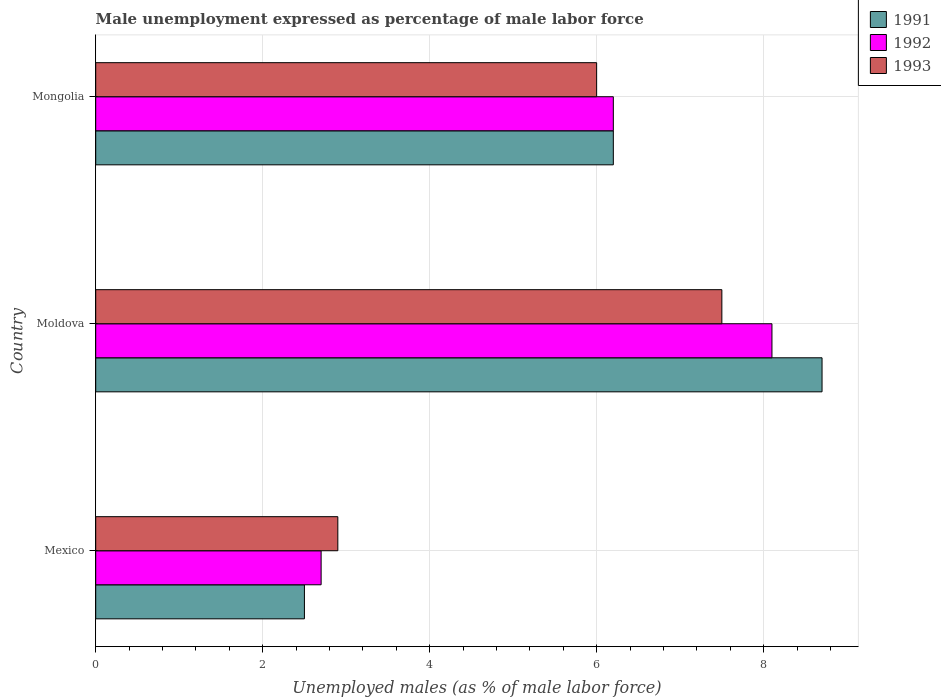How many different coloured bars are there?
Your answer should be very brief. 3. How many groups of bars are there?
Ensure brevity in your answer.  3. Are the number of bars on each tick of the Y-axis equal?
Keep it short and to the point. Yes. How many bars are there on the 3rd tick from the top?
Your answer should be compact. 3. How many bars are there on the 1st tick from the bottom?
Your response must be concise. 3. What is the label of the 3rd group of bars from the top?
Provide a succinct answer. Mexico. In how many cases, is the number of bars for a given country not equal to the number of legend labels?
Provide a succinct answer. 0. What is the unemployment in males in in 1993 in Mongolia?
Your answer should be compact. 6. Across all countries, what is the maximum unemployment in males in in 1991?
Offer a terse response. 8.7. Across all countries, what is the minimum unemployment in males in in 1992?
Give a very brief answer. 2.7. In which country was the unemployment in males in in 1991 maximum?
Provide a short and direct response. Moldova. What is the total unemployment in males in in 1991 in the graph?
Make the answer very short. 17.4. What is the difference between the unemployment in males in in 1991 in Mexico and that in Mongolia?
Provide a short and direct response. -3.7. What is the difference between the unemployment in males in in 1992 in Moldova and the unemployment in males in in 1993 in Mexico?
Provide a short and direct response. 5.2. What is the average unemployment in males in in 1993 per country?
Your answer should be compact. 5.47. What is the difference between the unemployment in males in in 1992 and unemployment in males in in 1991 in Moldova?
Make the answer very short. -0.6. What is the ratio of the unemployment in males in in 1992 in Mexico to that in Mongolia?
Your answer should be very brief. 0.44. What is the difference between the highest and the second highest unemployment in males in in 1993?
Keep it short and to the point. 1.5. What is the difference between the highest and the lowest unemployment in males in in 1991?
Provide a succinct answer. 6.2. In how many countries, is the unemployment in males in in 1992 greater than the average unemployment in males in in 1992 taken over all countries?
Your answer should be compact. 2. Is the sum of the unemployment in males in in 1993 in Mexico and Mongolia greater than the maximum unemployment in males in in 1991 across all countries?
Provide a succinct answer. Yes. What does the 3rd bar from the top in Moldova represents?
Offer a terse response. 1991. What does the 1st bar from the bottom in Mexico represents?
Offer a very short reply. 1991. Are all the bars in the graph horizontal?
Your answer should be compact. Yes. How many countries are there in the graph?
Your answer should be very brief. 3. Are the values on the major ticks of X-axis written in scientific E-notation?
Your answer should be compact. No. Where does the legend appear in the graph?
Keep it short and to the point. Top right. How are the legend labels stacked?
Your answer should be compact. Vertical. What is the title of the graph?
Ensure brevity in your answer.  Male unemployment expressed as percentage of male labor force. What is the label or title of the X-axis?
Your answer should be very brief. Unemployed males (as % of male labor force). What is the Unemployed males (as % of male labor force) of 1992 in Mexico?
Offer a terse response. 2.7. What is the Unemployed males (as % of male labor force) of 1993 in Mexico?
Provide a succinct answer. 2.9. What is the Unemployed males (as % of male labor force) of 1991 in Moldova?
Your answer should be compact. 8.7. What is the Unemployed males (as % of male labor force) of 1992 in Moldova?
Your response must be concise. 8.1. What is the Unemployed males (as % of male labor force) of 1993 in Moldova?
Your answer should be compact. 7.5. What is the Unemployed males (as % of male labor force) in 1991 in Mongolia?
Your answer should be very brief. 6.2. What is the Unemployed males (as % of male labor force) in 1992 in Mongolia?
Your answer should be very brief. 6.2. What is the Unemployed males (as % of male labor force) in 1993 in Mongolia?
Provide a short and direct response. 6. Across all countries, what is the maximum Unemployed males (as % of male labor force) of 1991?
Your response must be concise. 8.7. Across all countries, what is the maximum Unemployed males (as % of male labor force) in 1992?
Provide a short and direct response. 8.1. Across all countries, what is the maximum Unemployed males (as % of male labor force) of 1993?
Provide a short and direct response. 7.5. Across all countries, what is the minimum Unemployed males (as % of male labor force) of 1991?
Ensure brevity in your answer.  2.5. Across all countries, what is the minimum Unemployed males (as % of male labor force) in 1992?
Keep it short and to the point. 2.7. Across all countries, what is the minimum Unemployed males (as % of male labor force) in 1993?
Make the answer very short. 2.9. What is the total Unemployed males (as % of male labor force) of 1991 in the graph?
Ensure brevity in your answer.  17.4. What is the difference between the Unemployed males (as % of male labor force) of 1991 in Mexico and that in Moldova?
Provide a succinct answer. -6.2. What is the difference between the Unemployed males (as % of male labor force) in 1992 in Mexico and that in Moldova?
Ensure brevity in your answer.  -5.4. What is the difference between the Unemployed males (as % of male labor force) of 1993 in Mexico and that in Moldova?
Provide a succinct answer. -4.6. What is the difference between the Unemployed males (as % of male labor force) in 1991 in Mexico and that in Mongolia?
Offer a terse response. -3.7. What is the difference between the Unemployed males (as % of male labor force) of 1992 in Mexico and that in Mongolia?
Your answer should be very brief. -3.5. What is the difference between the Unemployed males (as % of male labor force) in 1992 in Moldova and that in Mongolia?
Make the answer very short. 1.9. What is the difference between the Unemployed males (as % of male labor force) of 1993 in Moldova and that in Mongolia?
Keep it short and to the point. 1.5. What is the difference between the Unemployed males (as % of male labor force) in 1991 in Mexico and the Unemployed males (as % of male labor force) in 1992 in Moldova?
Your answer should be compact. -5.6. What is the difference between the Unemployed males (as % of male labor force) of 1991 in Mexico and the Unemployed males (as % of male labor force) of 1993 in Moldova?
Make the answer very short. -5. What is the difference between the Unemployed males (as % of male labor force) in 1992 in Mexico and the Unemployed males (as % of male labor force) in 1993 in Moldova?
Offer a terse response. -4.8. What is the difference between the Unemployed males (as % of male labor force) in 1992 in Mexico and the Unemployed males (as % of male labor force) in 1993 in Mongolia?
Keep it short and to the point. -3.3. What is the difference between the Unemployed males (as % of male labor force) in 1991 in Moldova and the Unemployed males (as % of male labor force) in 1992 in Mongolia?
Offer a very short reply. 2.5. What is the difference between the Unemployed males (as % of male labor force) of 1991 in Moldova and the Unemployed males (as % of male labor force) of 1993 in Mongolia?
Offer a very short reply. 2.7. What is the average Unemployed males (as % of male labor force) in 1992 per country?
Offer a very short reply. 5.67. What is the average Unemployed males (as % of male labor force) of 1993 per country?
Offer a terse response. 5.47. What is the difference between the Unemployed males (as % of male labor force) of 1992 and Unemployed males (as % of male labor force) of 1993 in Mexico?
Provide a short and direct response. -0.2. What is the difference between the Unemployed males (as % of male labor force) in 1991 and Unemployed males (as % of male labor force) in 1993 in Moldova?
Offer a terse response. 1.2. What is the difference between the Unemployed males (as % of male labor force) in 1992 and Unemployed males (as % of male labor force) in 1993 in Moldova?
Your answer should be very brief. 0.6. What is the ratio of the Unemployed males (as % of male labor force) of 1991 in Mexico to that in Moldova?
Provide a short and direct response. 0.29. What is the ratio of the Unemployed males (as % of male labor force) in 1992 in Mexico to that in Moldova?
Provide a short and direct response. 0.33. What is the ratio of the Unemployed males (as % of male labor force) in 1993 in Mexico to that in Moldova?
Your answer should be compact. 0.39. What is the ratio of the Unemployed males (as % of male labor force) of 1991 in Mexico to that in Mongolia?
Make the answer very short. 0.4. What is the ratio of the Unemployed males (as % of male labor force) in 1992 in Mexico to that in Mongolia?
Your answer should be compact. 0.44. What is the ratio of the Unemployed males (as % of male labor force) in 1993 in Mexico to that in Mongolia?
Make the answer very short. 0.48. What is the ratio of the Unemployed males (as % of male labor force) of 1991 in Moldova to that in Mongolia?
Your answer should be compact. 1.4. What is the ratio of the Unemployed males (as % of male labor force) of 1992 in Moldova to that in Mongolia?
Your answer should be very brief. 1.31. What is the ratio of the Unemployed males (as % of male labor force) in 1993 in Moldova to that in Mongolia?
Your answer should be compact. 1.25. What is the difference between the highest and the second highest Unemployed males (as % of male labor force) in 1991?
Offer a very short reply. 2.5. What is the difference between the highest and the second highest Unemployed males (as % of male labor force) of 1992?
Your answer should be very brief. 1.9. What is the difference between the highest and the second highest Unemployed males (as % of male labor force) of 1993?
Make the answer very short. 1.5. What is the difference between the highest and the lowest Unemployed males (as % of male labor force) of 1991?
Offer a very short reply. 6.2. What is the difference between the highest and the lowest Unemployed males (as % of male labor force) of 1992?
Provide a succinct answer. 5.4. 